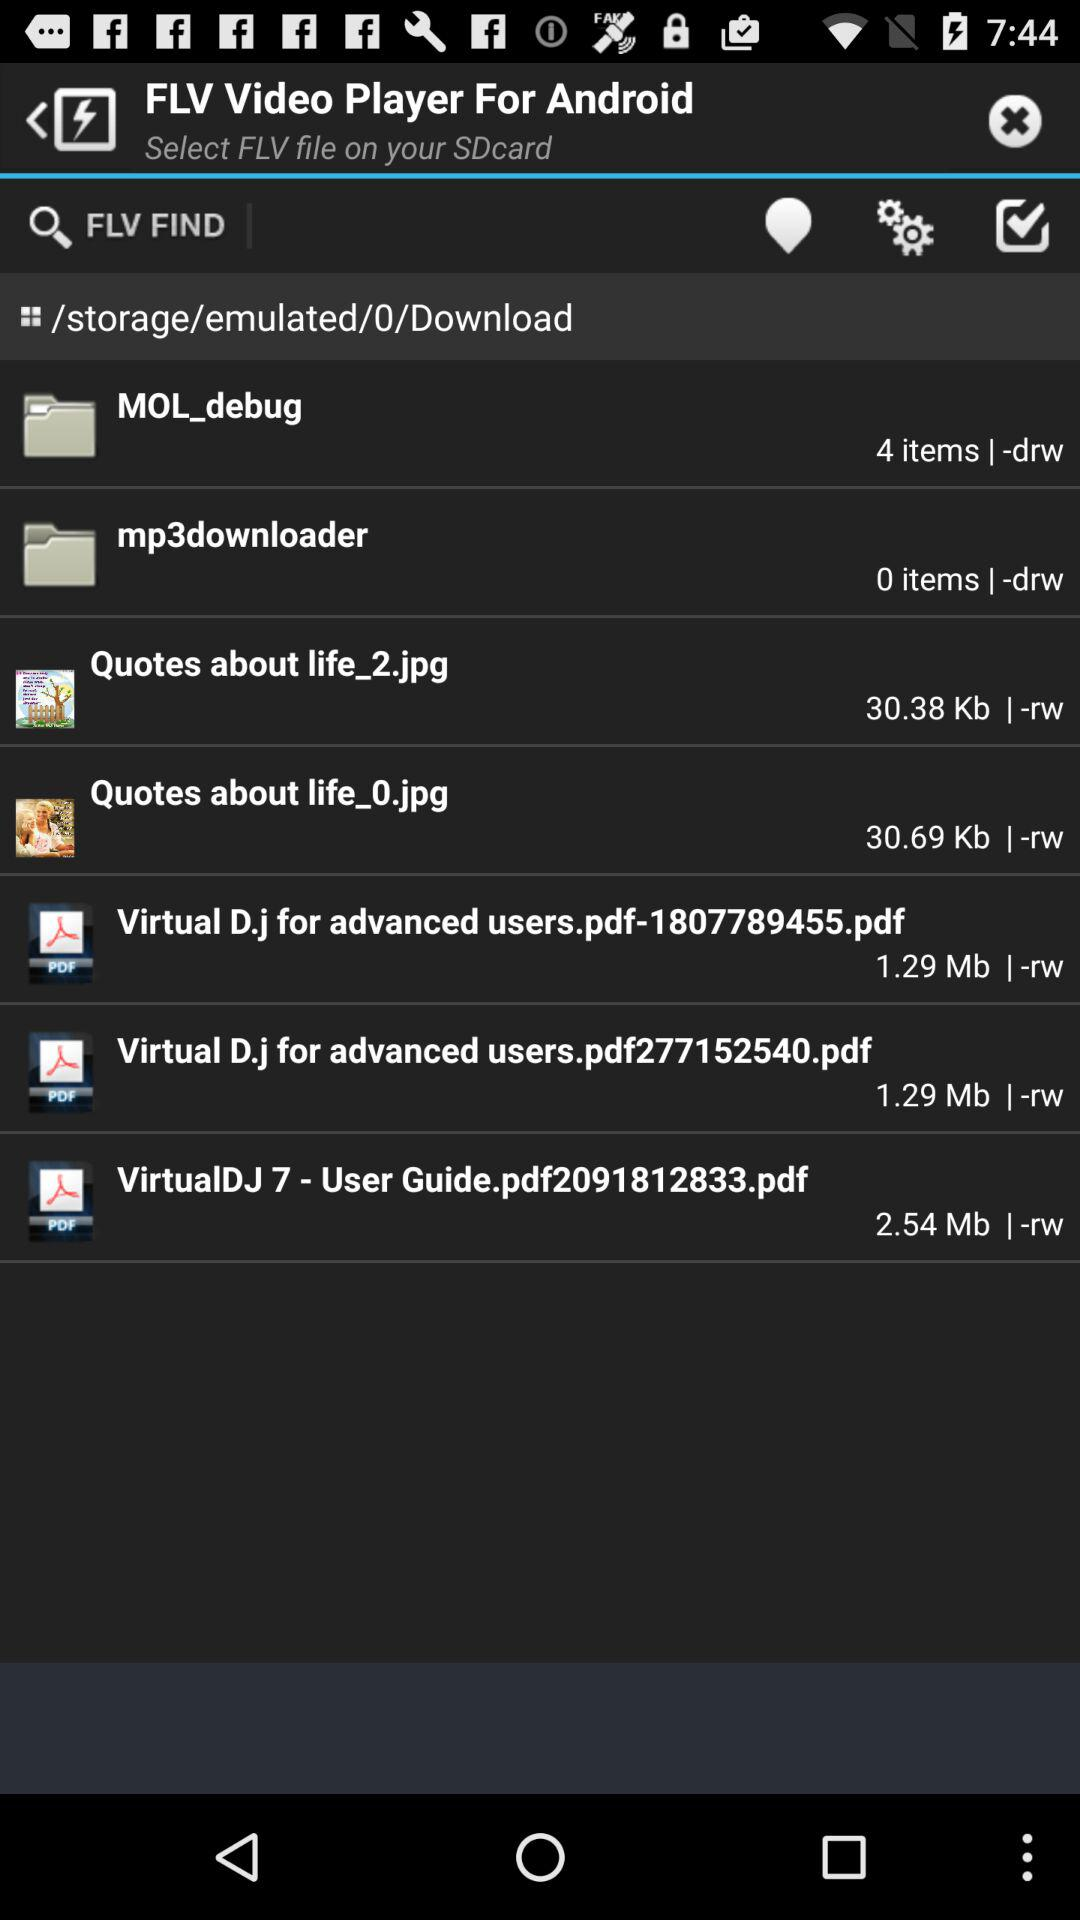Which image has a size of 30.38 kb? The image that has a size of 30.38 kb is "Quotes about life_2.jpg". 